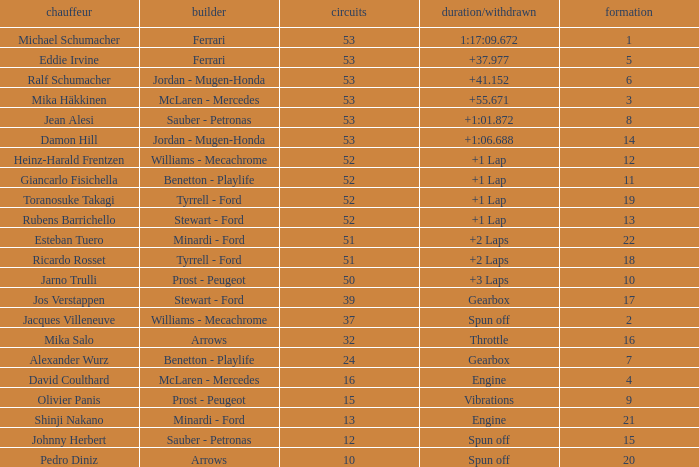Who built the car that went 53 laps with a Time/Retired of 1:17:09.672? Ferrari. 